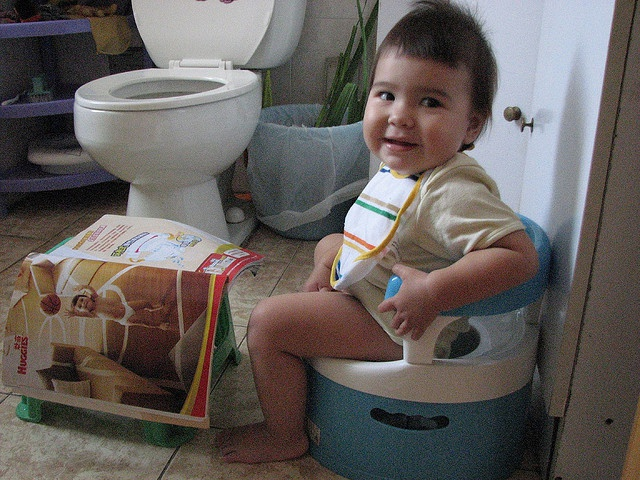Describe the objects in this image and their specific colors. I can see people in black, maroon, and gray tones, book in black, gray, and maroon tones, toilet in black, gray, purple, and darkblue tones, and toilet in black, darkgray, gray, and lightgray tones in this image. 